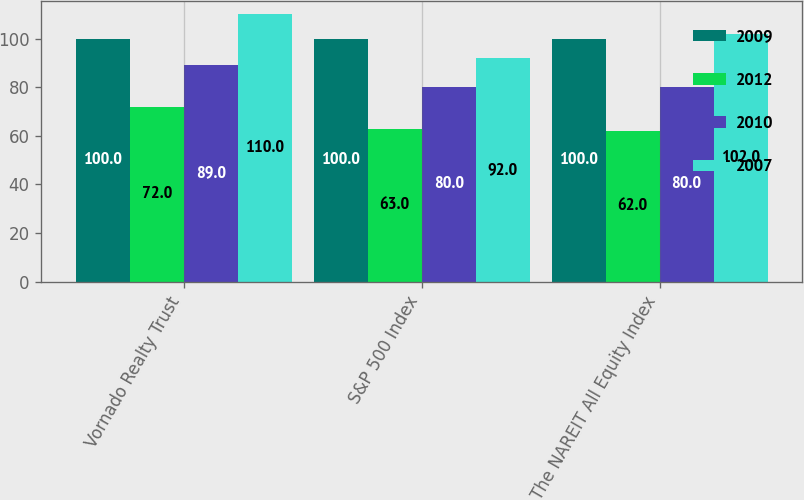Convert chart to OTSL. <chart><loc_0><loc_0><loc_500><loc_500><stacked_bar_chart><ecel><fcel>Vornado Realty Trust<fcel>S&P 500 Index<fcel>The NAREIT All Equity Index<nl><fcel>2009<fcel>100<fcel>100<fcel>100<nl><fcel>2012<fcel>72<fcel>63<fcel>62<nl><fcel>2010<fcel>89<fcel>80<fcel>80<nl><fcel>2007<fcel>110<fcel>92<fcel>102<nl></chart> 